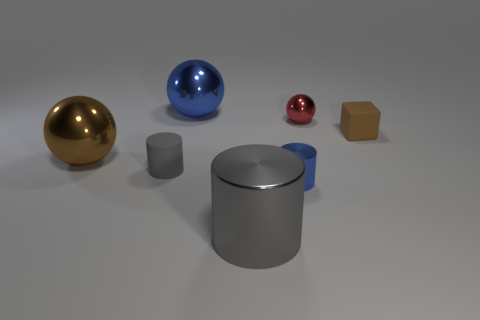Add 3 brown matte things. How many objects exist? 10 Subtract all cubes. How many objects are left? 6 Add 4 blue cylinders. How many blue cylinders are left? 5 Add 1 large gray metal cylinders. How many large gray metal cylinders exist? 2 Subtract 1 brown balls. How many objects are left? 6 Subtract all brown blocks. Subtract all small brown rubber cylinders. How many objects are left? 6 